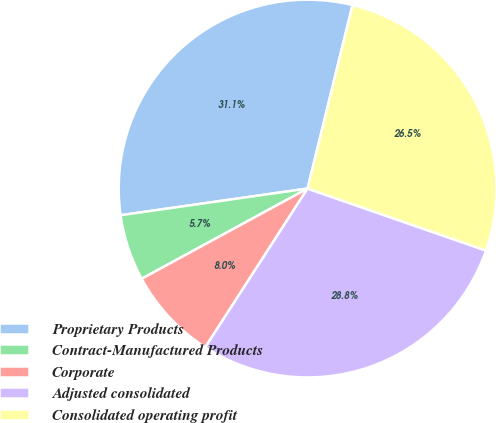Convert chart to OTSL. <chart><loc_0><loc_0><loc_500><loc_500><pie_chart><fcel>Proprietary Products<fcel>Contract-Manufactured Products<fcel>Corporate<fcel>Adjusted consolidated<fcel>Consolidated operating profit<nl><fcel>31.08%<fcel>5.67%<fcel>7.96%<fcel>28.79%<fcel>26.5%<nl></chart> 